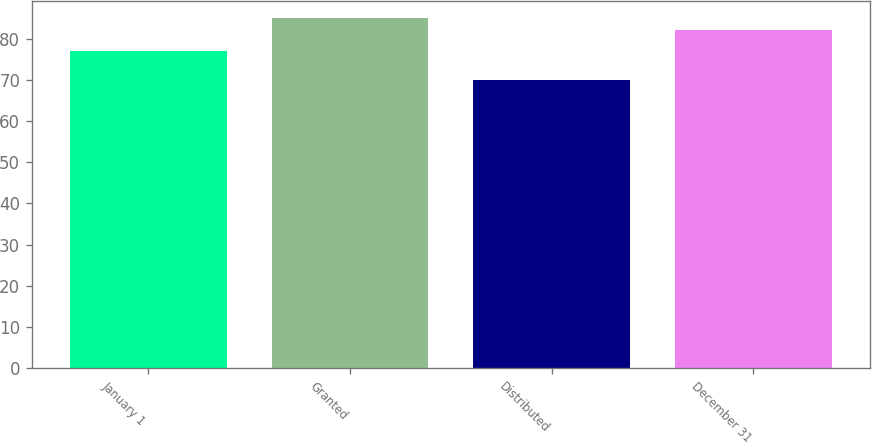Convert chart. <chart><loc_0><loc_0><loc_500><loc_500><bar_chart><fcel>January 1<fcel>Granted<fcel>Distributed<fcel>December 31<nl><fcel>77.05<fcel>84.94<fcel>69.89<fcel>82.01<nl></chart> 